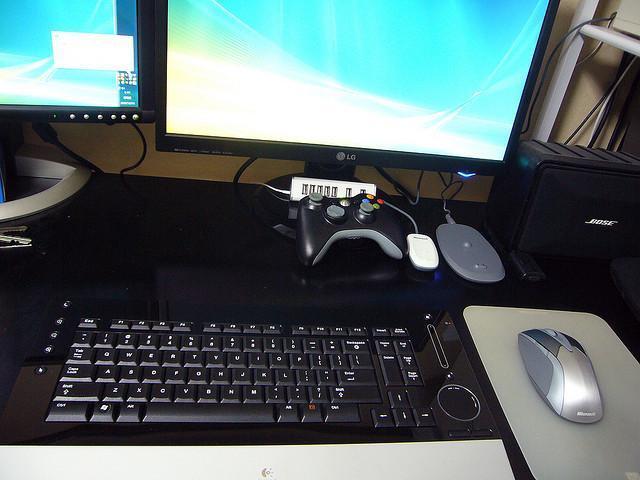How many monitors are there?
Give a very brief answer. 2. How many tvs are there?
Give a very brief answer. 2. How many people are wearing a red hat?
Give a very brief answer. 0. 